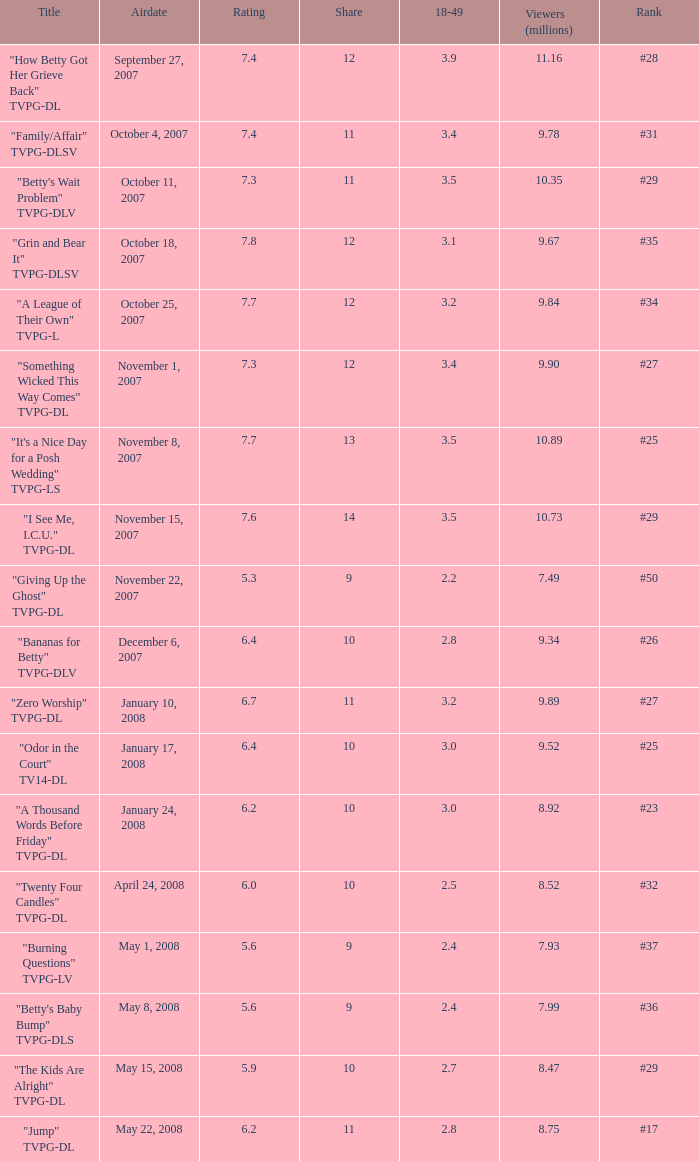What is the Airdate of the episode that ranked #29 and had a share greater than 10? May 15, 2008. 